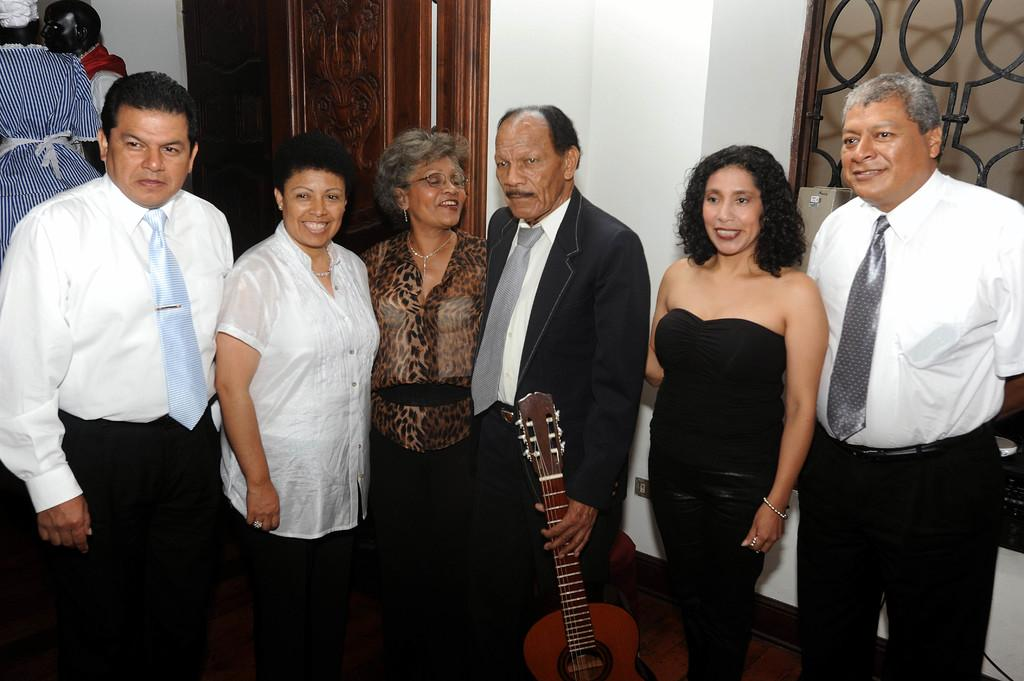What can be seen in the image? There is a group of people in the image. Can you describe the expressions of the people in the group? Two women in the group are smiling. What else is visible in the background of the image? There are statues in the background of the image. How many frogs are sitting on the glove in the image? There are no frogs or gloves present in the image. What type of education is being provided in the image? There is no indication of any educational activity in the image. 